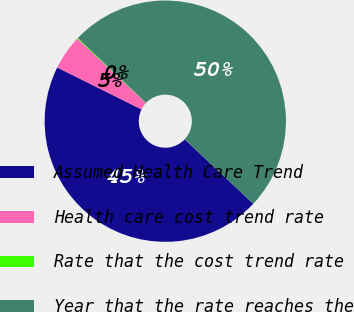<chart> <loc_0><loc_0><loc_500><loc_500><pie_chart><fcel>Assumed Health Care Trend<fcel>Health care cost trend rate<fcel>Rate that the cost trend rate<fcel>Year that the rate reaches the<nl><fcel>45.35%<fcel>4.65%<fcel>0.11%<fcel>49.89%<nl></chart> 